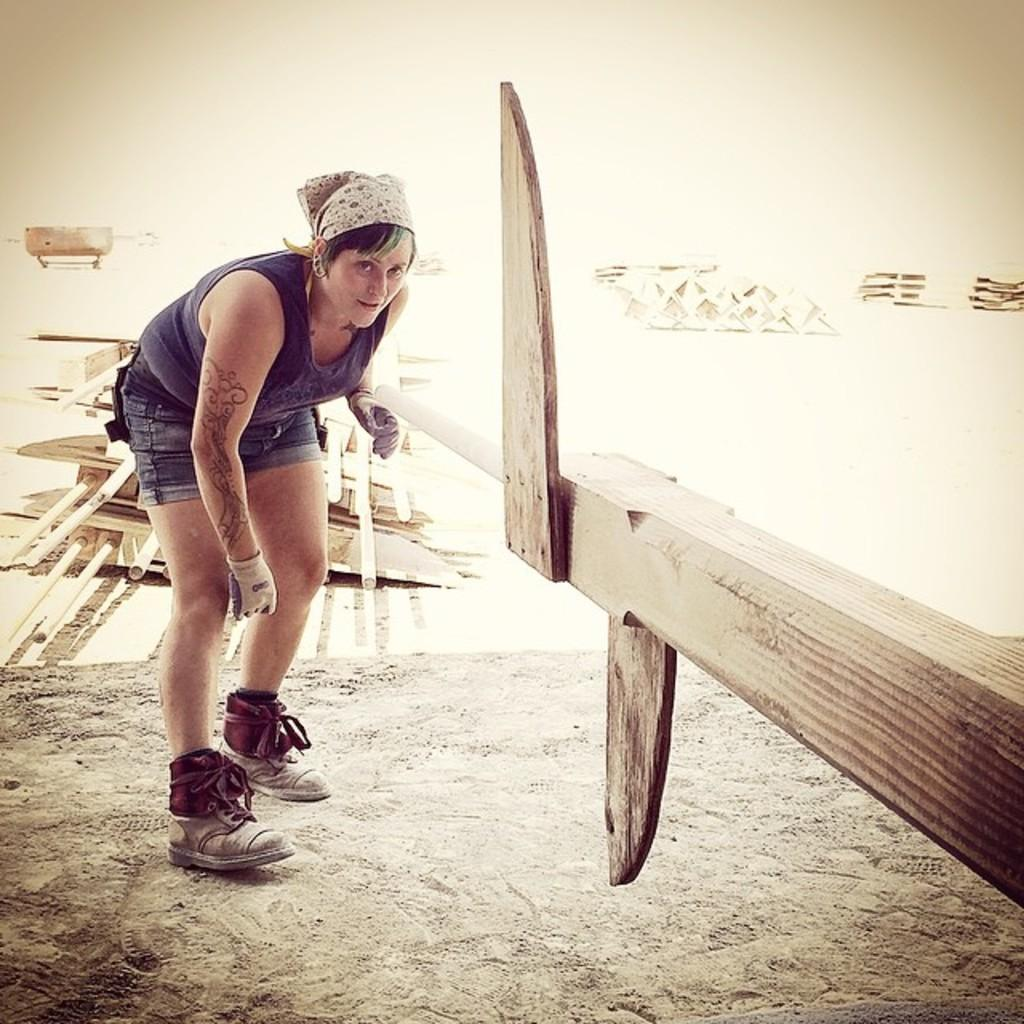Who is present in the image? There is a woman in the image. What is the woman doing in the image? The woman is standing on the ground in the image. What object is the woman holding in the image? The woman is holding a wooden stick in the image. Where is the wooden stick positioned in relation to the woman? The wooden stick is in front of her. What can be seen in the background of the image? There are poles in the background of the image. How are the poles positioned in the image? The poles are on the ground in the image. What type of snow can be seen falling in the image? There is no snow present in the image. What station is the woman operating in the image? The image does not depict a station or any activity related to operating a station. 